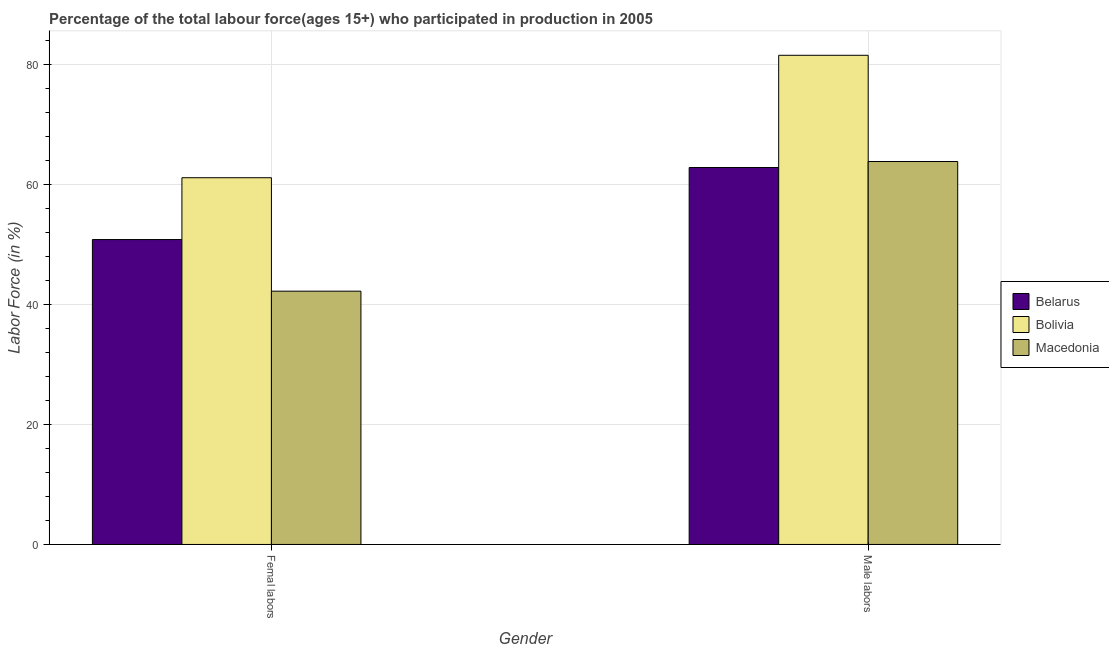Are the number of bars per tick equal to the number of legend labels?
Offer a very short reply. Yes. How many bars are there on the 2nd tick from the left?
Offer a terse response. 3. What is the label of the 2nd group of bars from the left?
Offer a terse response. Male labors. What is the percentage of male labour force in Macedonia?
Keep it short and to the point. 63.8. Across all countries, what is the maximum percentage of female labor force?
Give a very brief answer. 61.1. Across all countries, what is the minimum percentage of male labour force?
Give a very brief answer. 62.8. In which country was the percentage of male labour force minimum?
Ensure brevity in your answer.  Belarus. What is the total percentage of female labor force in the graph?
Your response must be concise. 154.1. What is the difference between the percentage of female labor force in Bolivia and that in Macedonia?
Your response must be concise. 18.9. What is the difference between the percentage of female labor force in Belarus and the percentage of male labour force in Macedonia?
Your answer should be compact. -13. What is the average percentage of female labor force per country?
Your response must be concise. 51.37. In how many countries, is the percentage of female labor force greater than 20 %?
Provide a succinct answer. 3. What is the ratio of the percentage of female labor force in Macedonia to that in Bolivia?
Ensure brevity in your answer.  0.69. What does the 3rd bar from the left in Male labors represents?
Give a very brief answer. Macedonia. What does the 2nd bar from the right in Male labors represents?
Ensure brevity in your answer.  Bolivia. Are all the bars in the graph horizontal?
Offer a terse response. No. Are the values on the major ticks of Y-axis written in scientific E-notation?
Your answer should be compact. No. Does the graph contain any zero values?
Make the answer very short. No. Does the graph contain grids?
Your answer should be compact. Yes. Where does the legend appear in the graph?
Provide a succinct answer. Center right. How many legend labels are there?
Ensure brevity in your answer.  3. What is the title of the graph?
Offer a terse response. Percentage of the total labour force(ages 15+) who participated in production in 2005. Does "Tuvalu" appear as one of the legend labels in the graph?
Your answer should be compact. No. What is the Labor Force (in %) of Belarus in Femal labors?
Offer a very short reply. 50.8. What is the Labor Force (in %) of Bolivia in Femal labors?
Provide a short and direct response. 61.1. What is the Labor Force (in %) in Macedonia in Femal labors?
Your answer should be very brief. 42.2. What is the Labor Force (in %) in Belarus in Male labors?
Ensure brevity in your answer.  62.8. What is the Labor Force (in %) in Bolivia in Male labors?
Give a very brief answer. 81.5. What is the Labor Force (in %) in Macedonia in Male labors?
Keep it short and to the point. 63.8. Across all Gender, what is the maximum Labor Force (in %) of Belarus?
Make the answer very short. 62.8. Across all Gender, what is the maximum Labor Force (in %) of Bolivia?
Your response must be concise. 81.5. Across all Gender, what is the maximum Labor Force (in %) of Macedonia?
Offer a very short reply. 63.8. Across all Gender, what is the minimum Labor Force (in %) in Belarus?
Give a very brief answer. 50.8. Across all Gender, what is the minimum Labor Force (in %) in Bolivia?
Keep it short and to the point. 61.1. Across all Gender, what is the minimum Labor Force (in %) in Macedonia?
Keep it short and to the point. 42.2. What is the total Labor Force (in %) of Belarus in the graph?
Make the answer very short. 113.6. What is the total Labor Force (in %) of Bolivia in the graph?
Your answer should be compact. 142.6. What is the total Labor Force (in %) in Macedonia in the graph?
Your answer should be very brief. 106. What is the difference between the Labor Force (in %) in Bolivia in Femal labors and that in Male labors?
Ensure brevity in your answer.  -20.4. What is the difference between the Labor Force (in %) of Macedonia in Femal labors and that in Male labors?
Provide a short and direct response. -21.6. What is the difference between the Labor Force (in %) in Belarus in Femal labors and the Labor Force (in %) in Bolivia in Male labors?
Your answer should be very brief. -30.7. What is the difference between the Labor Force (in %) of Belarus in Femal labors and the Labor Force (in %) of Macedonia in Male labors?
Ensure brevity in your answer.  -13. What is the average Labor Force (in %) of Belarus per Gender?
Make the answer very short. 56.8. What is the average Labor Force (in %) in Bolivia per Gender?
Your answer should be compact. 71.3. What is the difference between the Labor Force (in %) in Belarus and Labor Force (in %) in Macedonia in Femal labors?
Offer a very short reply. 8.6. What is the difference between the Labor Force (in %) of Belarus and Labor Force (in %) of Bolivia in Male labors?
Your answer should be very brief. -18.7. What is the difference between the Labor Force (in %) of Belarus and Labor Force (in %) of Macedonia in Male labors?
Ensure brevity in your answer.  -1. What is the ratio of the Labor Force (in %) of Belarus in Femal labors to that in Male labors?
Keep it short and to the point. 0.81. What is the ratio of the Labor Force (in %) of Bolivia in Femal labors to that in Male labors?
Offer a terse response. 0.75. What is the ratio of the Labor Force (in %) of Macedonia in Femal labors to that in Male labors?
Keep it short and to the point. 0.66. What is the difference between the highest and the second highest Labor Force (in %) of Bolivia?
Keep it short and to the point. 20.4. What is the difference between the highest and the second highest Labor Force (in %) in Macedonia?
Your response must be concise. 21.6. What is the difference between the highest and the lowest Labor Force (in %) in Belarus?
Ensure brevity in your answer.  12. What is the difference between the highest and the lowest Labor Force (in %) of Bolivia?
Make the answer very short. 20.4. What is the difference between the highest and the lowest Labor Force (in %) in Macedonia?
Provide a short and direct response. 21.6. 